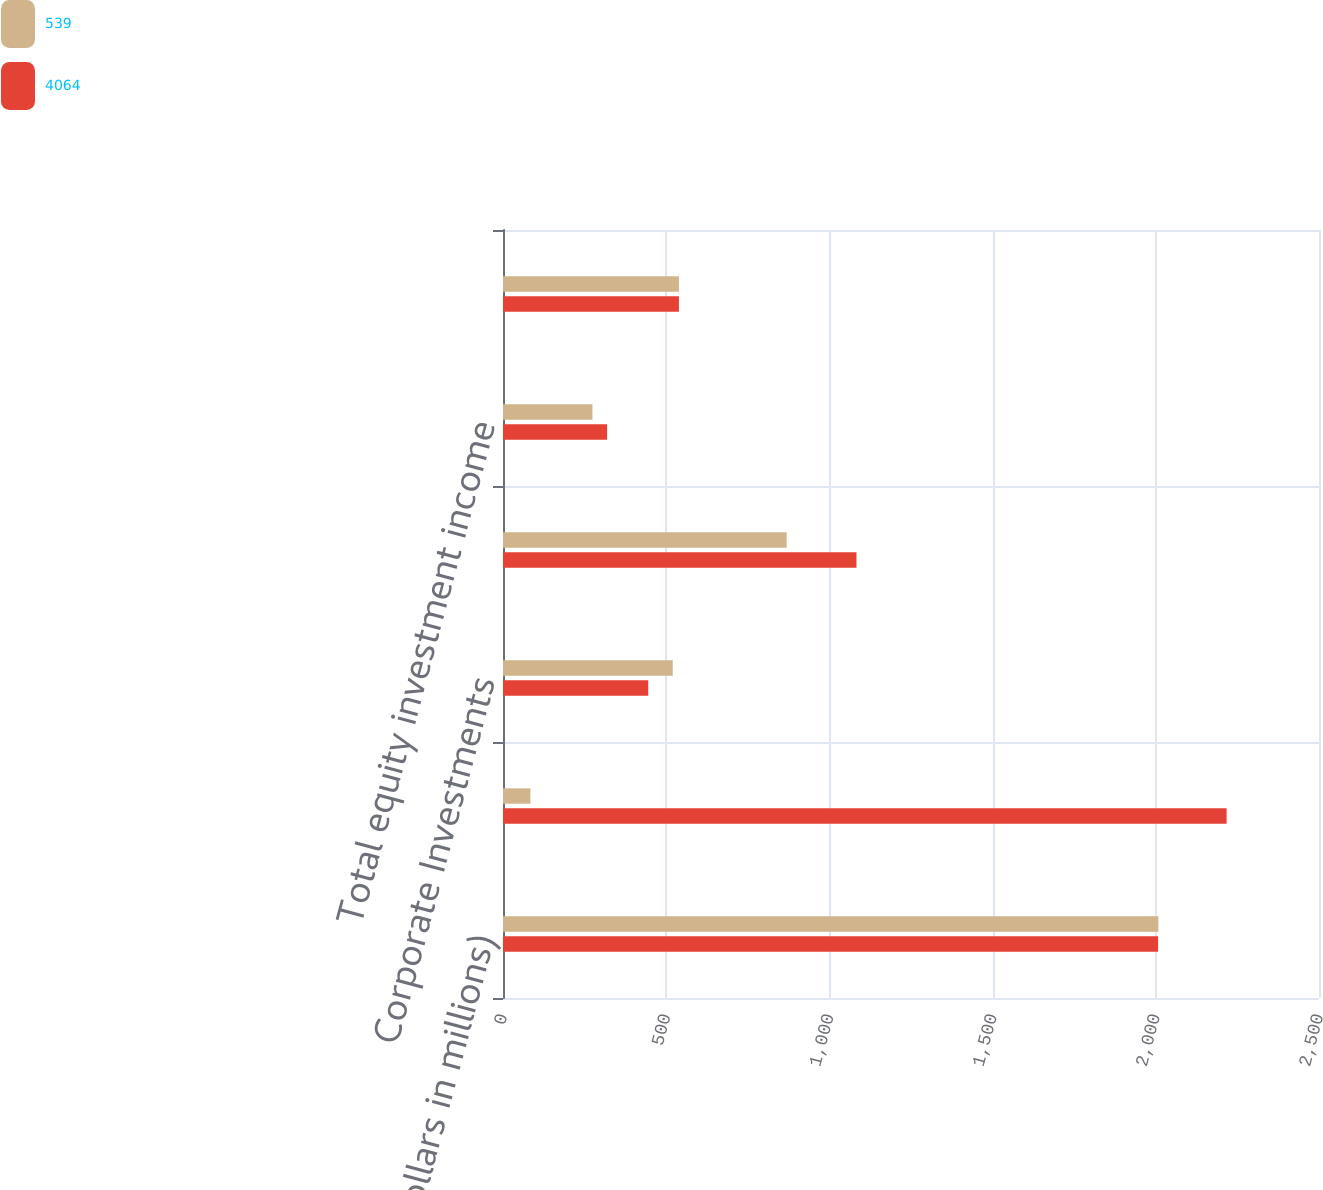<chart> <loc_0><loc_0><loc_500><loc_500><stacked_bar_chart><ecel><fcel>(Dollars in millions)<fcel>Principal Investing<fcel>Corporate Investments<fcel>Strategic and other<fcel>Total equity investment income<fcel>Total consolidated equity<nl><fcel>539<fcel>2008<fcel>84<fcel>520<fcel>869<fcel>274<fcel>539<nl><fcel>4064<fcel>2007<fcel>2217<fcel>445<fcel>1083<fcel>319<fcel>539<nl></chart> 